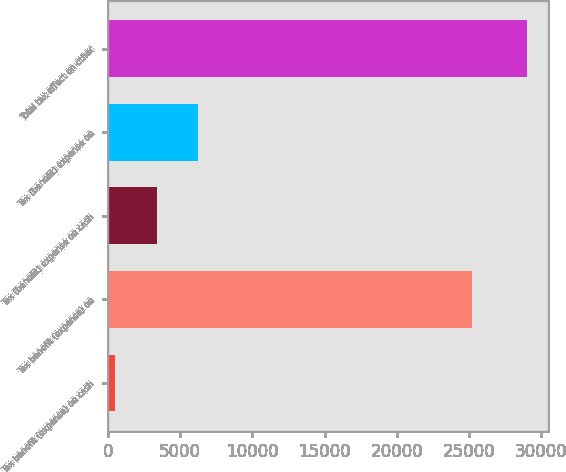Convert chart. <chart><loc_0><loc_0><loc_500><loc_500><bar_chart><fcel>Tax benefit (expense) on cash<fcel>Tax benefit (expense) on<fcel>Tax (benefit) expense on cash<fcel>Tax (benefit) expense on<fcel>Total tax effect on other<nl><fcel>511<fcel>25193<fcel>3363.2<fcel>6215.4<fcel>29033<nl></chart> 